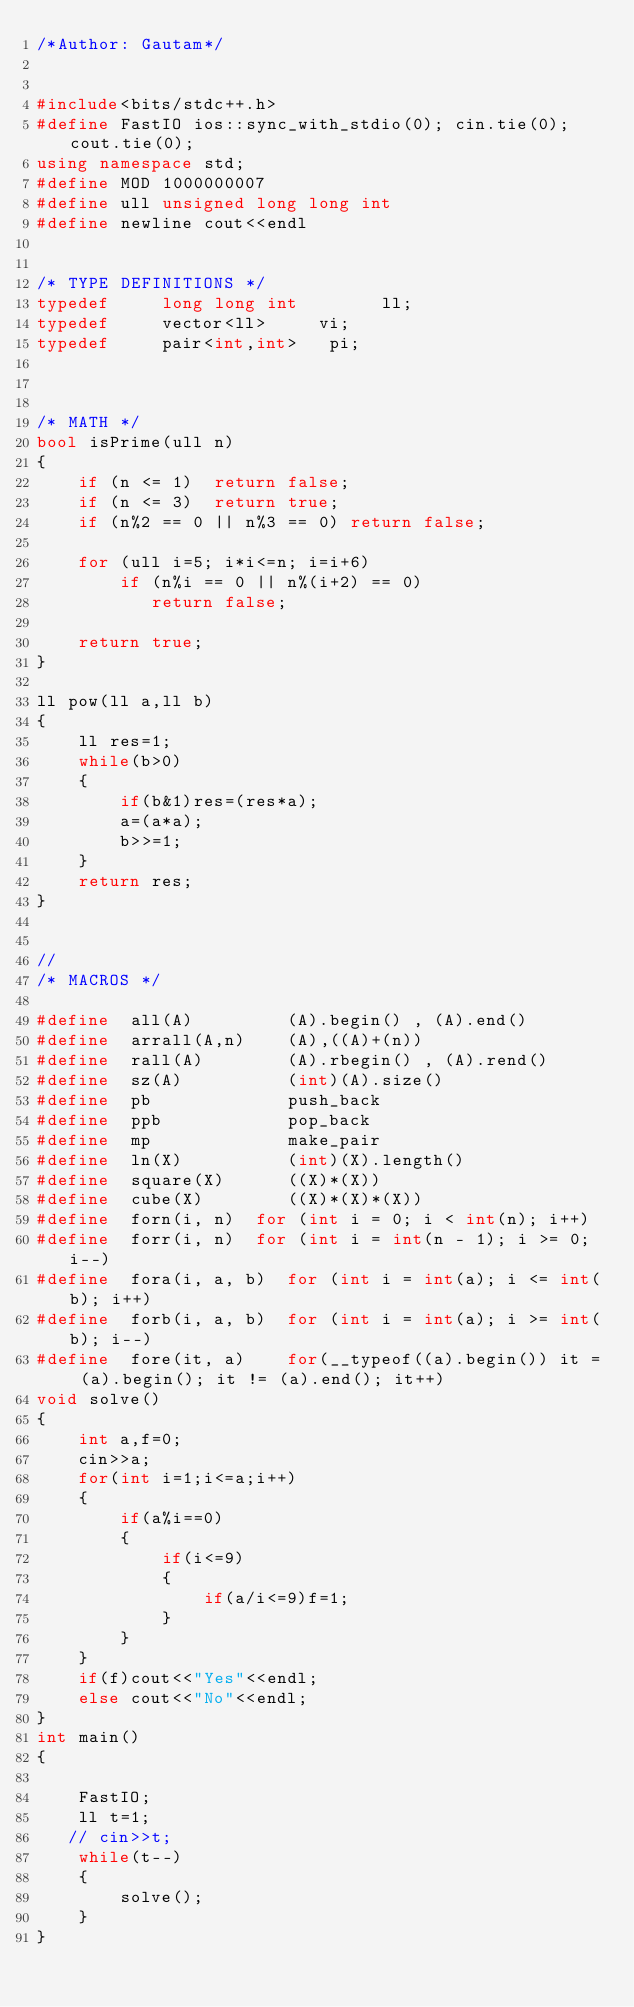<code> <loc_0><loc_0><loc_500><loc_500><_C++_>/*Author: Gautam*/
 
 
#include<bits/stdc++.h>
#define FastIO ios::sync_with_stdio(0); cin.tie(0); cout.tie(0);
using namespace std;
#define MOD 1000000007
#define ull unsigned long long int
#define newline cout<<endl
 
 
/* TYPE DEFINITIONS */
typedef     long long int        ll;
typedef     vector<ll>     vi;
typedef     pair<int,int>   pi;
 
 
 
/* MATH */
bool isPrime(ull n) 
{ 
    if (n <= 1)  return false; 
    if (n <= 3)  return true; 
    if (n%2 == 0 || n%3 == 0) return false; 
  
    for (ull i=5; i*i<=n; i=i+6) 
        if (n%i == 0 || n%(i+2) == 0) 
           return false; 
  
    return true; 
} 
 
ll pow(ll a,ll b)
{
    ll res=1;
    while(b>0)
    {
        if(b&1)res=(res*a);
        a=(a*a);
        b>>=1;
    }
    return res;
}

  
//
/* MACROS */
 
#define  all(A)         (A).begin() , (A).end()
#define  arrall(A,n)    (A),((A)+(n))
#define  rall(A)        (A).rbegin() , (A).rend()
#define  sz(A)          (int)(A).size()
#define  pb             push_back
#define  ppb            pop_back
#define  mp             make_pair
#define  ln(X)          (int)(X).length()
#define  square(X)      ((X)*(X))
#define  cube(X)        ((X)*(X)*(X))
#define  forn(i, n)  for (int i = 0; i < int(n); i++)
#define  forr(i, n)  for (int i = int(n - 1); i >= 0; i--)
#define  fora(i, a, b)  for (int i = int(a); i <= int(b); i++)
#define  forb(i, a, b)  for (int i = int(a); i >= int(b); i--)
#define  fore(it, a)    for(__typeof((a).begin()) it = (a).begin(); it != (a).end(); it++) 
void solve()
{
    int a,f=0;
    cin>>a;
    for(int i=1;i<=a;i++)
    {
        if(a%i==0)
        {
            if(i<=9)
            {
                if(a/i<=9)f=1;
            }
        }
    }
    if(f)cout<<"Yes"<<endl;
    else cout<<"No"<<endl;
}  
int main()
{
 
    FastIO;
    ll t=1;
   // cin>>t;
    while(t--)
    {
        solve();
    }
}</code> 